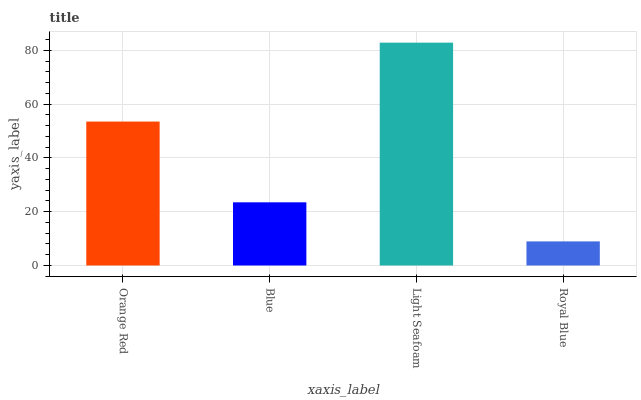Is Royal Blue the minimum?
Answer yes or no. Yes. Is Light Seafoam the maximum?
Answer yes or no. Yes. Is Blue the minimum?
Answer yes or no. No. Is Blue the maximum?
Answer yes or no. No. Is Orange Red greater than Blue?
Answer yes or no. Yes. Is Blue less than Orange Red?
Answer yes or no. Yes. Is Blue greater than Orange Red?
Answer yes or no. No. Is Orange Red less than Blue?
Answer yes or no. No. Is Orange Red the high median?
Answer yes or no. Yes. Is Blue the low median?
Answer yes or no. Yes. Is Light Seafoam the high median?
Answer yes or no. No. Is Royal Blue the low median?
Answer yes or no. No. 